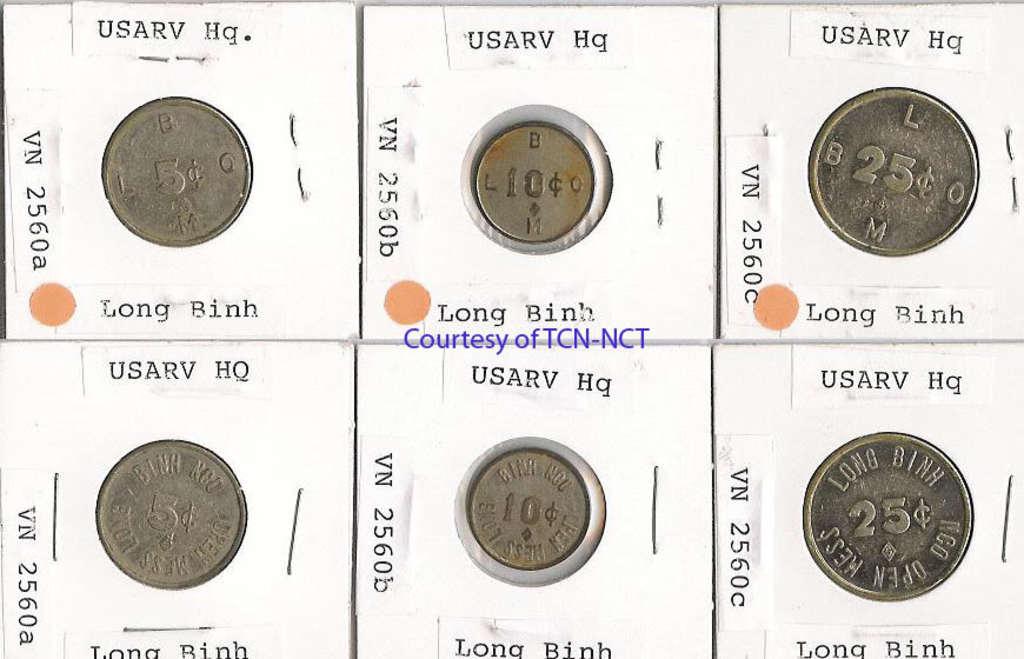What is the number of the coin on the top left?
Make the answer very short. 5. What is the number of the coin on the top right?
Ensure brevity in your answer.  25. 